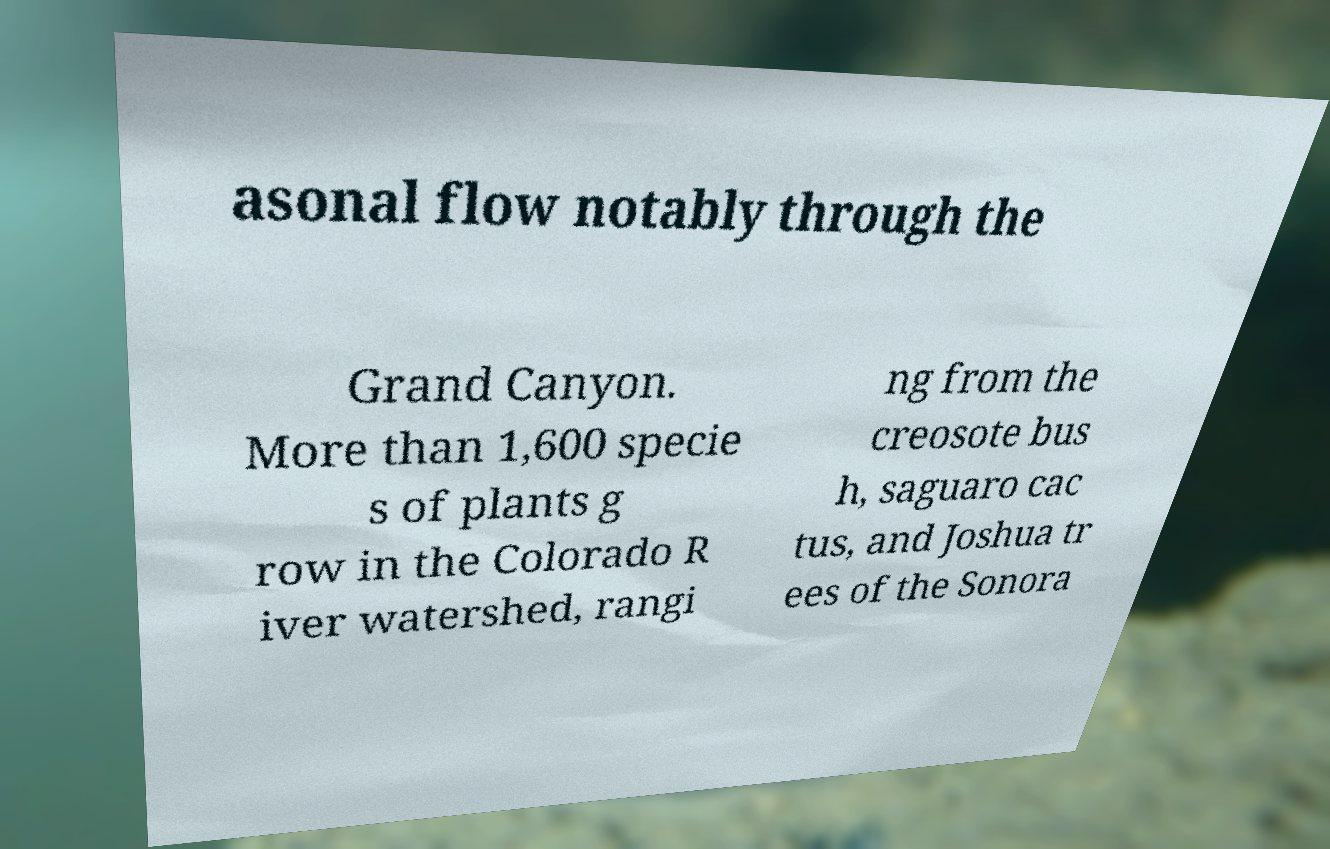What messages or text are displayed in this image? I need them in a readable, typed format. asonal flow notably through the Grand Canyon. More than 1,600 specie s of plants g row in the Colorado R iver watershed, rangi ng from the creosote bus h, saguaro cac tus, and Joshua tr ees of the Sonora 